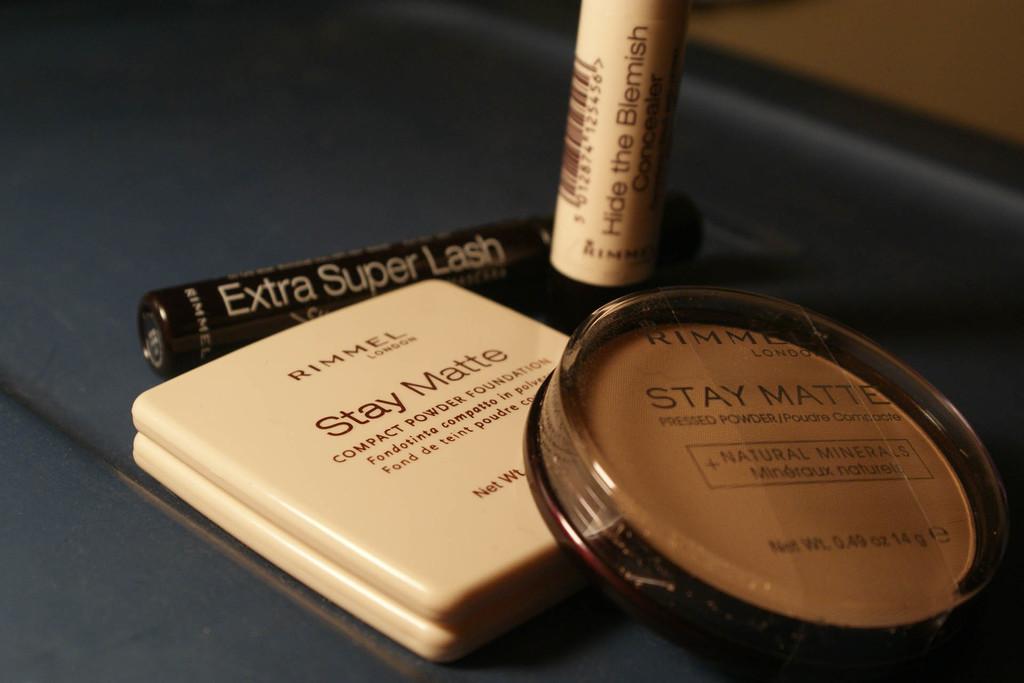What makeup brand is this?
Your answer should be very brief. Rimmel. What can one do with the blemish?
Provide a short and direct response. Hide it. 